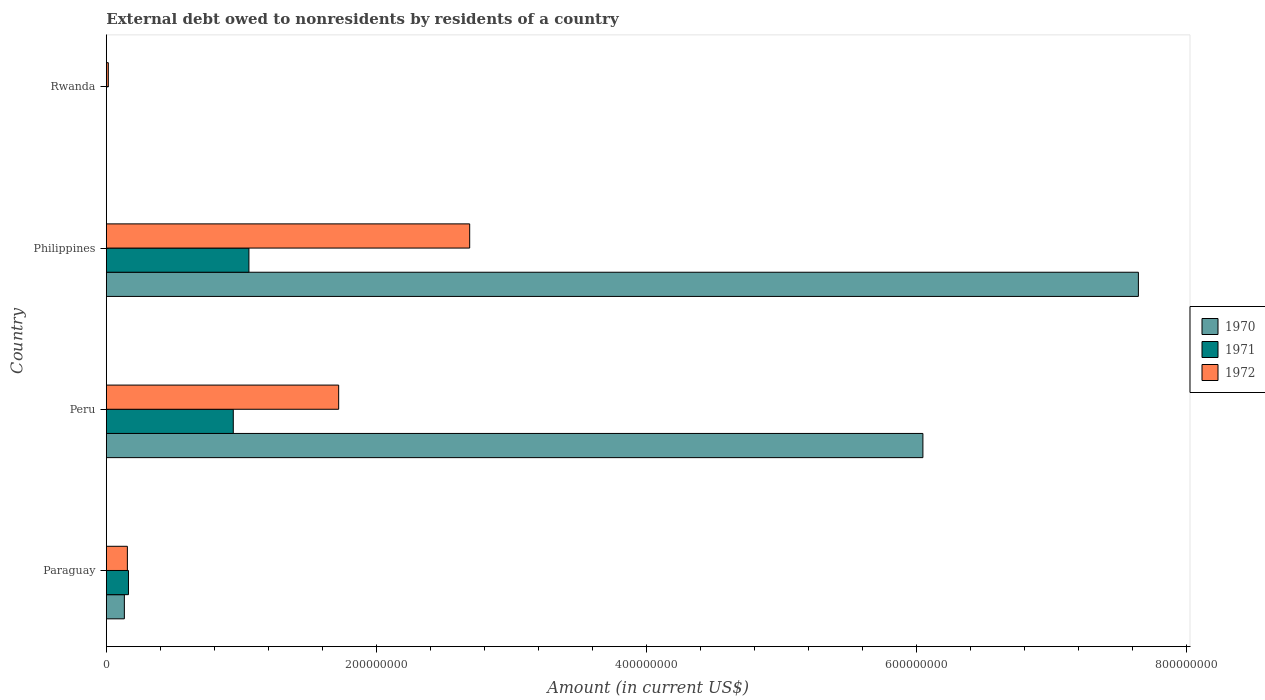How many different coloured bars are there?
Provide a succinct answer. 3. Are the number of bars on each tick of the Y-axis equal?
Offer a terse response. No. How many bars are there on the 1st tick from the bottom?
Keep it short and to the point. 3. What is the external debt owed by residents in 1970 in Philippines?
Your answer should be compact. 7.65e+08. Across all countries, what is the maximum external debt owed by residents in 1970?
Ensure brevity in your answer.  7.65e+08. In which country was the external debt owed by residents in 1971 maximum?
Make the answer very short. Philippines. What is the total external debt owed by residents in 1970 in the graph?
Your response must be concise. 1.38e+09. What is the difference between the external debt owed by residents in 1972 in Philippines and that in Rwanda?
Your response must be concise. 2.68e+08. What is the difference between the external debt owed by residents in 1971 in Peru and the external debt owed by residents in 1970 in Philippines?
Provide a short and direct response. -6.71e+08. What is the average external debt owed by residents in 1970 per country?
Offer a terse response. 3.46e+08. What is the difference between the external debt owed by residents in 1971 and external debt owed by residents in 1972 in Peru?
Offer a terse response. -7.81e+07. In how many countries, is the external debt owed by residents in 1972 greater than 400000000 US$?
Your response must be concise. 0. What is the ratio of the external debt owed by residents in 1970 in Paraguay to that in Peru?
Your answer should be very brief. 0.02. What is the difference between the highest and the second highest external debt owed by residents in 1971?
Your answer should be very brief. 1.16e+07. What is the difference between the highest and the lowest external debt owed by residents in 1971?
Your answer should be very brief. 1.06e+08. How many bars are there?
Provide a short and direct response. 10. Are all the bars in the graph horizontal?
Provide a short and direct response. Yes. What is the difference between two consecutive major ticks on the X-axis?
Your answer should be very brief. 2.00e+08. Does the graph contain any zero values?
Provide a succinct answer. Yes. How many legend labels are there?
Keep it short and to the point. 3. What is the title of the graph?
Ensure brevity in your answer.  External debt owed to nonresidents by residents of a country. Does "1992" appear as one of the legend labels in the graph?
Your answer should be very brief. No. What is the label or title of the X-axis?
Offer a terse response. Amount (in current US$). What is the label or title of the Y-axis?
Offer a terse response. Country. What is the Amount (in current US$) in 1970 in Paraguay?
Your answer should be very brief. 1.34e+07. What is the Amount (in current US$) in 1971 in Paraguay?
Your response must be concise. 1.64e+07. What is the Amount (in current US$) in 1972 in Paraguay?
Give a very brief answer. 1.56e+07. What is the Amount (in current US$) of 1970 in Peru?
Offer a terse response. 6.05e+08. What is the Amount (in current US$) in 1971 in Peru?
Your response must be concise. 9.41e+07. What is the Amount (in current US$) of 1972 in Peru?
Give a very brief answer. 1.72e+08. What is the Amount (in current US$) in 1970 in Philippines?
Give a very brief answer. 7.65e+08. What is the Amount (in current US$) in 1971 in Philippines?
Your response must be concise. 1.06e+08. What is the Amount (in current US$) of 1972 in Philippines?
Your response must be concise. 2.69e+08. What is the Amount (in current US$) in 1971 in Rwanda?
Keep it short and to the point. 0. What is the Amount (in current US$) in 1972 in Rwanda?
Ensure brevity in your answer.  1.46e+06. Across all countries, what is the maximum Amount (in current US$) of 1970?
Ensure brevity in your answer.  7.65e+08. Across all countries, what is the maximum Amount (in current US$) in 1971?
Provide a short and direct response. 1.06e+08. Across all countries, what is the maximum Amount (in current US$) of 1972?
Keep it short and to the point. 2.69e+08. Across all countries, what is the minimum Amount (in current US$) in 1971?
Provide a short and direct response. 0. Across all countries, what is the minimum Amount (in current US$) of 1972?
Your answer should be compact. 1.46e+06. What is the total Amount (in current US$) of 1970 in the graph?
Provide a succinct answer. 1.38e+09. What is the total Amount (in current US$) of 1971 in the graph?
Your answer should be compact. 2.16e+08. What is the total Amount (in current US$) in 1972 in the graph?
Your response must be concise. 4.58e+08. What is the difference between the Amount (in current US$) in 1970 in Paraguay and that in Peru?
Offer a very short reply. -5.92e+08. What is the difference between the Amount (in current US$) of 1971 in Paraguay and that in Peru?
Offer a terse response. -7.76e+07. What is the difference between the Amount (in current US$) in 1972 in Paraguay and that in Peru?
Your answer should be compact. -1.57e+08. What is the difference between the Amount (in current US$) in 1970 in Paraguay and that in Philippines?
Your response must be concise. -7.51e+08. What is the difference between the Amount (in current US$) of 1971 in Paraguay and that in Philippines?
Your response must be concise. -8.92e+07. What is the difference between the Amount (in current US$) in 1972 in Paraguay and that in Philippines?
Ensure brevity in your answer.  -2.54e+08. What is the difference between the Amount (in current US$) of 1972 in Paraguay and that in Rwanda?
Give a very brief answer. 1.41e+07. What is the difference between the Amount (in current US$) of 1970 in Peru and that in Philippines?
Provide a succinct answer. -1.60e+08. What is the difference between the Amount (in current US$) of 1971 in Peru and that in Philippines?
Offer a very short reply. -1.16e+07. What is the difference between the Amount (in current US$) in 1972 in Peru and that in Philippines?
Provide a succinct answer. -9.71e+07. What is the difference between the Amount (in current US$) in 1972 in Peru and that in Rwanda?
Keep it short and to the point. 1.71e+08. What is the difference between the Amount (in current US$) in 1972 in Philippines and that in Rwanda?
Your answer should be very brief. 2.68e+08. What is the difference between the Amount (in current US$) of 1970 in Paraguay and the Amount (in current US$) of 1971 in Peru?
Your response must be concise. -8.07e+07. What is the difference between the Amount (in current US$) of 1970 in Paraguay and the Amount (in current US$) of 1972 in Peru?
Ensure brevity in your answer.  -1.59e+08. What is the difference between the Amount (in current US$) of 1971 in Paraguay and the Amount (in current US$) of 1972 in Peru?
Your answer should be very brief. -1.56e+08. What is the difference between the Amount (in current US$) of 1970 in Paraguay and the Amount (in current US$) of 1971 in Philippines?
Offer a terse response. -9.23e+07. What is the difference between the Amount (in current US$) in 1970 in Paraguay and the Amount (in current US$) in 1972 in Philippines?
Provide a succinct answer. -2.56e+08. What is the difference between the Amount (in current US$) in 1971 in Paraguay and the Amount (in current US$) in 1972 in Philippines?
Ensure brevity in your answer.  -2.53e+08. What is the difference between the Amount (in current US$) in 1970 in Paraguay and the Amount (in current US$) in 1972 in Rwanda?
Provide a succinct answer. 1.19e+07. What is the difference between the Amount (in current US$) in 1971 in Paraguay and the Amount (in current US$) in 1972 in Rwanda?
Provide a short and direct response. 1.49e+07. What is the difference between the Amount (in current US$) in 1970 in Peru and the Amount (in current US$) in 1971 in Philippines?
Offer a terse response. 4.99e+08. What is the difference between the Amount (in current US$) in 1970 in Peru and the Amount (in current US$) in 1972 in Philippines?
Make the answer very short. 3.36e+08. What is the difference between the Amount (in current US$) of 1971 in Peru and the Amount (in current US$) of 1972 in Philippines?
Keep it short and to the point. -1.75e+08. What is the difference between the Amount (in current US$) of 1970 in Peru and the Amount (in current US$) of 1972 in Rwanda?
Provide a short and direct response. 6.04e+08. What is the difference between the Amount (in current US$) of 1971 in Peru and the Amount (in current US$) of 1972 in Rwanda?
Keep it short and to the point. 9.26e+07. What is the difference between the Amount (in current US$) of 1970 in Philippines and the Amount (in current US$) of 1972 in Rwanda?
Your answer should be very brief. 7.63e+08. What is the difference between the Amount (in current US$) of 1971 in Philippines and the Amount (in current US$) of 1972 in Rwanda?
Provide a succinct answer. 1.04e+08. What is the average Amount (in current US$) of 1970 per country?
Give a very brief answer. 3.46e+08. What is the average Amount (in current US$) of 1971 per country?
Make the answer very short. 5.40e+07. What is the average Amount (in current US$) in 1972 per country?
Your answer should be compact. 1.15e+08. What is the difference between the Amount (in current US$) of 1970 and Amount (in current US$) of 1971 in Paraguay?
Give a very brief answer. -3.05e+06. What is the difference between the Amount (in current US$) in 1970 and Amount (in current US$) in 1972 in Paraguay?
Your answer should be very brief. -2.23e+06. What is the difference between the Amount (in current US$) of 1971 and Amount (in current US$) of 1972 in Paraguay?
Offer a terse response. 8.15e+05. What is the difference between the Amount (in current US$) of 1970 and Amount (in current US$) of 1971 in Peru?
Your response must be concise. 5.11e+08. What is the difference between the Amount (in current US$) of 1970 and Amount (in current US$) of 1972 in Peru?
Your answer should be very brief. 4.33e+08. What is the difference between the Amount (in current US$) of 1971 and Amount (in current US$) of 1972 in Peru?
Your response must be concise. -7.81e+07. What is the difference between the Amount (in current US$) in 1970 and Amount (in current US$) in 1971 in Philippines?
Make the answer very short. 6.59e+08. What is the difference between the Amount (in current US$) in 1970 and Amount (in current US$) in 1972 in Philippines?
Offer a terse response. 4.95e+08. What is the difference between the Amount (in current US$) in 1971 and Amount (in current US$) in 1972 in Philippines?
Give a very brief answer. -1.64e+08. What is the ratio of the Amount (in current US$) in 1970 in Paraguay to that in Peru?
Provide a short and direct response. 0.02. What is the ratio of the Amount (in current US$) of 1971 in Paraguay to that in Peru?
Ensure brevity in your answer.  0.17. What is the ratio of the Amount (in current US$) of 1972 in Paraguay to that in Peru?
Provide a succinct answer. 0.09. What is the ratio of the Amount (in current US$) in 1970 in Paraguay to that in Philippines?
Offer a terse response. 0.02. What is the ratio of the Amount (in current US$) of 1971 in Paraguay to that in Philippines?
Offer a terse response. 0.16. What is the ratio of the Amount (in current US$) of 1972 in Paraguay to that in Philippines?
Give a very brief answer. 0.06. What is the ratio of the Amount (in current US$) in 1972 in Paraguay to that in Rwanda?
Give a very brief answer. 10.65. What is the ratio of the Amount (in current US$) in 1970 in Peru to that in Philippines?
Provide a short and direct response. 0.79. What is the ratio of the Amount (in current US$) of 1971 in Peru to that in Philippines?
Give a very brief answer. 0.89. What is the ratio of the Amount (in current US$) in 1972 in Peru to that in Philippines?
Make the answer very short. 0.64. What is the ratio of the Amount (in current US$) of 1972 in Peru to that in Rwanda?
Give a very brief answer. 117.59. What is the ratio of the Amount (in current US$) in 1972 in Philippines to that in Rwanda?
Make the answer very short. 183.9. What is the difference between the highest and the second highest Amount (in current US$) of 1970?
Your answer should be compact. 1.60e+08. What is the difference between the highest and the second highest Amount (in current US$) of 1971?
Your answer should be very brief. 1.16e+07. What is the difference between the highest and the second highest Amount (in current US$) of 1972?
Your answer should be very brief. 9.71e+07. What is the difference between the highest and the lowest Amount (in current US$) in 1970?
Ensure brevity in your answer.  7.65e+08. What is the difference between the highest and the lowest Amount (in current US$) in 1971?
Keep it short and to the point. 1.06e+08. What is the difference between the highest and the lowest Amount (in current US$) of 1972?
Provide a short and direct response. 2.68e+08. 